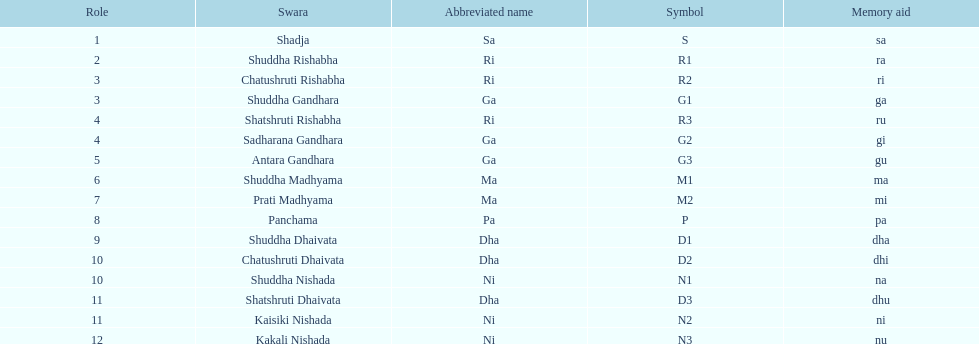Typically, how many swara feature a concise name commencing with d or g? 6. 